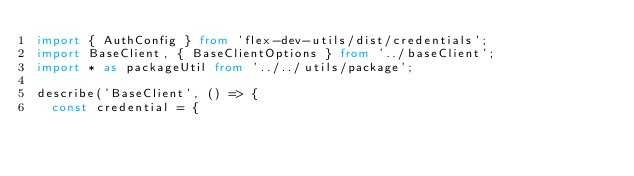<code> <loc_0><loc_0><loc_500><loc_500><_TypeScript_>import { AuthConfig } from 'flex-dev-utils/dist/credentials';
import BaseClient, { BaseClientOptions } from '../baseClient';
import * as packageUtil from '../../utils/package';

describe('BaseClient', () => {
  const credential = {</code> 